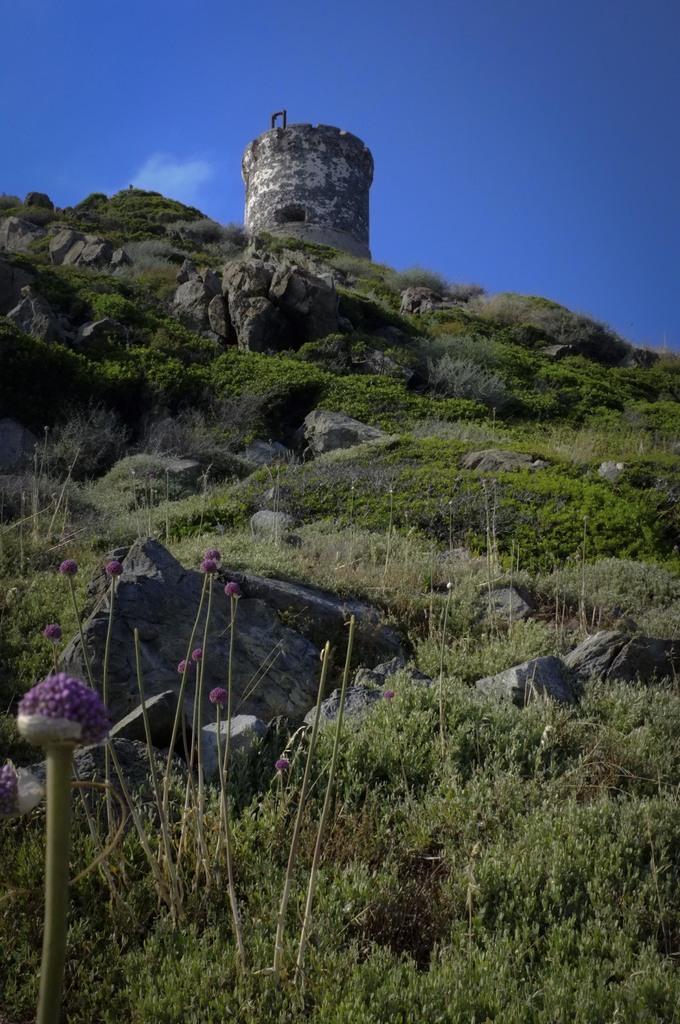In one or two sentences, can you explain what this image depicts? This is the picture of a hill on which there are some plants, grass and some rocks and at the top there is a building like thing. 